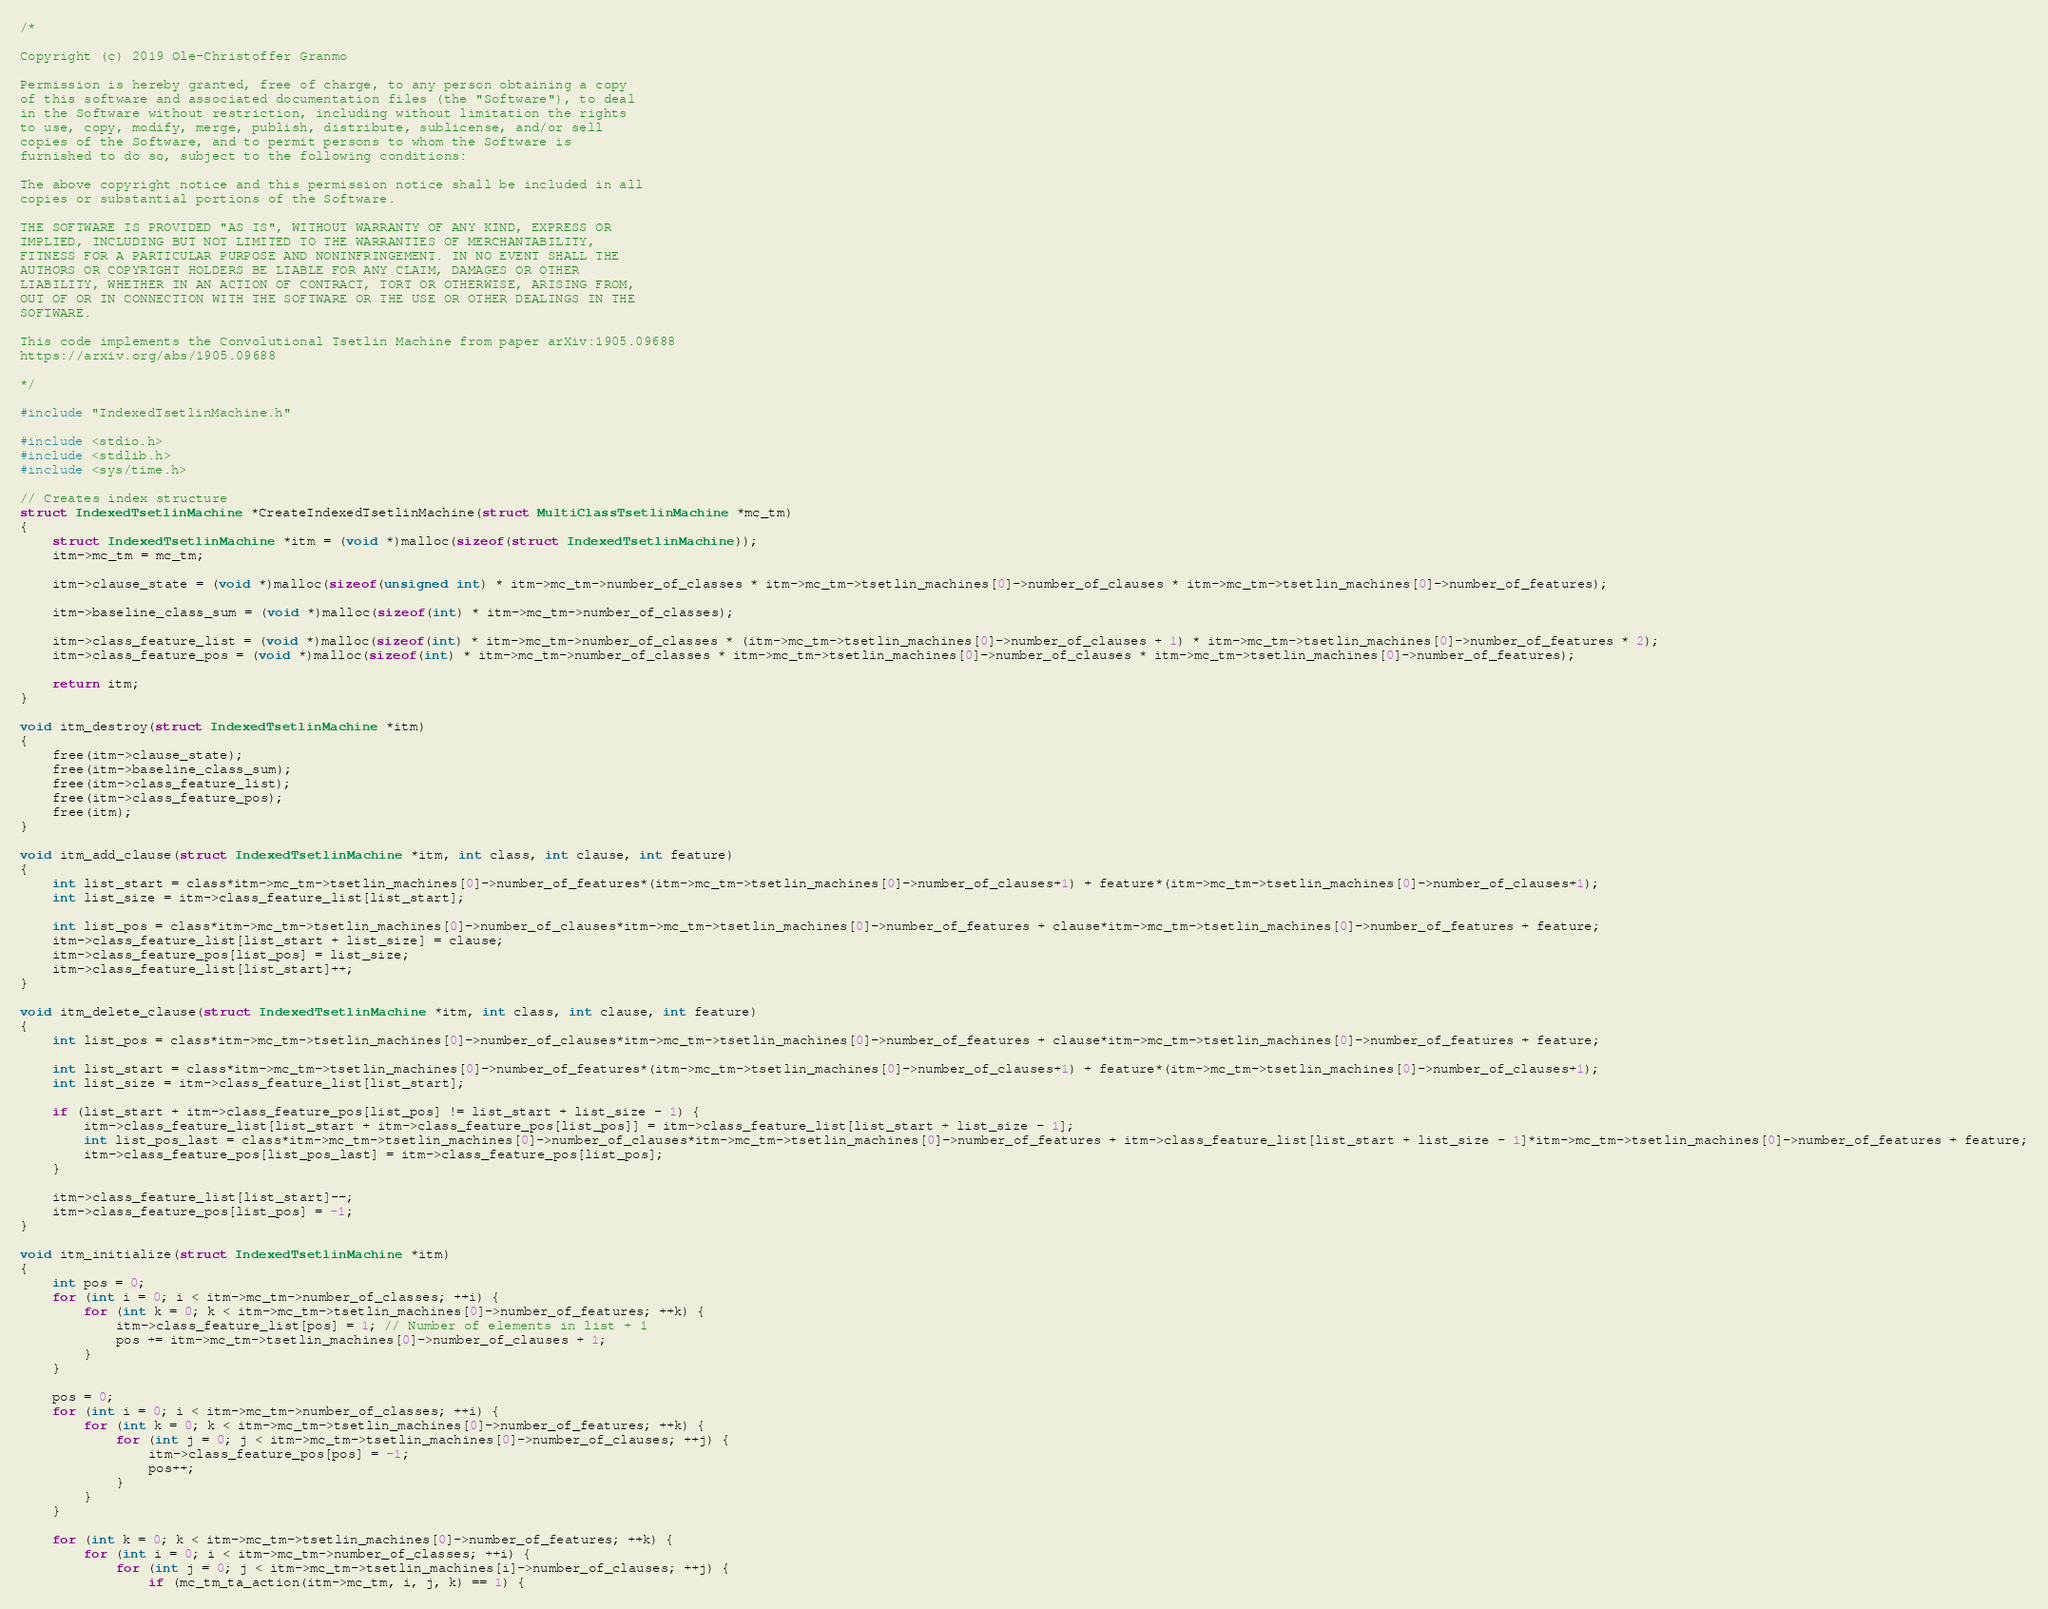<code> <loc_0><loc_0><loc_500><loc_500><_C_>/*

Copyright (c) 2019 Ole-Christoffer Granmo

Permission is hereby granted, free of charge, to any person obtaining a copy
of this software and associated documentation files (the "Software"), to deal
in the Software without restriction, including without limitation the rights
to use, copy, modify, merge, publish, distribute, sublicense, and/or sell
copies of the Software, and to permit persons to whom the Software is
furnished to do so, subject to the following conditions:

The above copyright notice and this permission notice shall be included in all
copies or substantial portions of the Software.

THE SOFTWARE IS PROVIDED "AS IS", WITHOUT WARRANTY OF ANY KIND, EXPRESS OR
IMPLIED, INCLUDING BUT NOT LIMITED TO THE WARRANTIES OF MERCHANTABILITY,
FITNESS FOR A PARTICULAR PURPOSE AND NONINFRINGEMENT. IN NO EVENT SHALL THE
AUTHORS OR COPYRIGHT HOLDERS BE LIABLE FOR ANY CLAIM, DAMAGES OR OTHER
LIABILITY, WHETHER IN AN ACTION OF CONTRACT, TORT OR OTHERWISE, ARISING FROM,
OUT OF OR IN CONNECTION WITH THE SOFTWARE OR THE USE OR OTHER DEALINGS IN THE
SOFTWARE.

This code implements the Convolutional Tsetlin Machine from paper arXiv:1905.09688
https://arxiv.org/abs/1905.09688

*/

#include "IndexedTsetlinMachine.h"

#include <stdio.h>
#include <stdlib.h>
#include <sys/time.h>

// Creates index structure
struct IndexedTsetlinMachine *CreateIndexedTsetlinMachine(struct MultiClassTsetlinMachine *mc_tm)
{
	struct IndexedTsetlinMachine *itm = (void *)malloc(sizeof(struct IndexedTsetlinMachine));
	itm->mc_tm = mc_tm;

	itm->clause_state = (void *)malloc(sizeof(unsigned int) * itm->mc_tm->number_of_classes * itm->mc_tm->tsetlin_machines[0]->number_of_clauses * itm->mc_tm->tsetlin_machines[0]->number_of_features);

	itm->baseline_class_sum = (void *)malloc(sizeof(int) * itm->mc_tm->number_of_classes);

	itm->class_feature_list = (void *)malloc(sizeof(int) * itm->mc_tm->number_of_classes * (itm->mc_tm->tsetlin_machines[0]->number_of_clauses + 1) * itm->mc_tm->tsetlin_machines[0]->number_of_features * 2);
	itm->class_feature_pos = (void *)malloc(sizeof(int) * itm->mc_tm->number_of_classes * itm->mc_tm->tsetlin_machines[0]->number_of_clauses * itm->mc_tm->tsetlin_machines[0]->number_of_features);

	return itm;
}

void itm_destroy(struct IndexedTsetlinMachine *itm)
{
	free(itm->clause_state);
	free(itm->baseline_class_sum);
	free(itm->class_feature_list);
	free(itm->class_feature_pos);
	free(itm);
}

void itm_add_clause(struct IndexedTsetlinMachine *itm, int class, int clause, int feature)
{	
	int list_start = class*itm->mc_tm->tsetlin_machines[0]->number_of_features*(itm->mc_tm->tsetlin_machines[0]->number_of_clauses+1) + feature*(itm->mc_tm->tsetlin_machines[0]->number_of_clauses+1);
	int list_size = itm->class_feature_list[list_start];

	int list_pos = class*itm->mc_tm->tsetlin_machines[0]->number_of_clauses*itm->mc_tm->tsetlin_machines[0]->number_of_features + clause*itm->mc_tm->tsetlin_machines[0]->number_of_features + feature;
	itm->class_feature_list[list_start + list_size] = clause;
	itm->class_feature_pos[list_pos] = list_size;
	itm->class_feature_list[list_start]++;
}

void itm_delete_clause(struct IndexedTsetlinMachine *itm, int class, int clause, int feature)
{
	int list_pos = class*itm->mc_tm->tsetlin_machines[0]->number_of_clauses*itm->mc_tm->tsetlin_machines[0]->number_of_features + clause*itm->mc_tm->tsetlin_machines[0]->number_of_features + feature;

	int list_start = class*itm->mc_tm->tsetlin_machines[0]->number_of_features*(itm->mc_tm->tsetlin_machines[0]->number_of_clauses+1) + feature*(itm->mc_tm->tsetlin_machines[0]->number_of_clauses+1);
	int list_size = itm->class_feature_list[list_start];

	if (list_start + itm->class_feature_pos[list_pos] != list_start + list_size - 1) {
		itm->class_feature_list[list_start + itm->class_feature_pos[list_pos]] = itm->class_feature_list[list_start + list_size - 1];
		int list_pos_last = class*itm->mc_tm->tsetlin_machines[0]->number_of_clauses*itm->mc_tm->tsetlin_machines[0]->number_of_features + itm->class_feature_list[list_start + list_size - 1]*itm->mc_tm->tsetlin_machines[0]->number_of_features + feature;
		itm->class_feature_pos[list_pos_last] = itm->class_feature_pos[list_pos];
	}

	itm->class_feature_list[list_start]--;
	itm->class_feature_pos[list_pos] = -1;
}

void itm_initialize(struct IndexedTsetlinMachine *itm)
{
	int pos = 0;
	for (int i = 0; i < itm->mc_tm->number_of_classes; ++i) {
		for (int k = 0; k < itm->mc_tm->tsetlin_machines[0]->number_of_features; ++k) {
			itm->class_feature_list[pos] = 1; // Number of elements in list + 1
			pos += itm->mc_tm->tsetlin_machines[0]->number_of_clauses + 1;
		}
	}

	pos = 0;
	for (int i = 0; i < itm->mc_tm->number_of_classes; ++i) {
		for (int k = 0; k < itm->mc_tm->tsetlin_machines[0]->number_of_features; ++k) {
			for (int j = 0; j < itm->mc_tm->tsetlin_machines[0]->number_of_clauses; ++j) {
				itm->class_feature_pos[pos] = -1;
				pos++;
			}
		}
	}

	for (int k = 0; k < itm->mc_tm->tsetlin_machines[0]->number_of_features; ++k) {
		for (int i = 0; i < itm->mc_tm->number_of_classes; ++i) {
			for (int j = 0; j < itm->mc_tm->tsetlin_machines[i]->number_of_clauses; ++j) {
				if (mc_tm_ta_action(itm->mc_tm, i, j, k) == 1) {</code> 